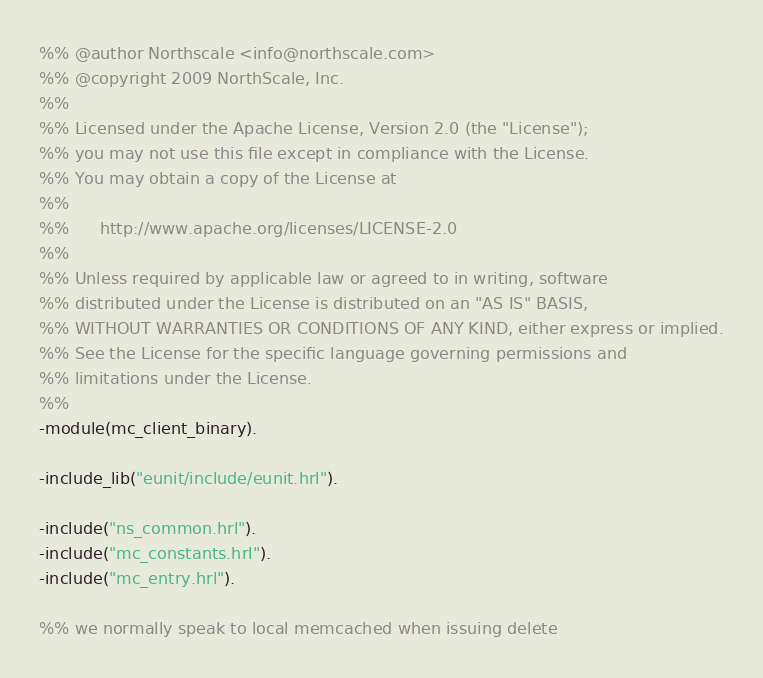Convert code to text. <code><loc_0><loc_0><loc_500><loc_500><_Erlang_>%% @author Northscale <info@northscale.com>
%% @copyright 2009 NorthScale, Inc.
%%
%% Licensed under the Apache License, Version 2.0 (the "License");
%% you may not use this file except in compliance with the License.
%% You may obtain a copy of the License at
%%
%%      http://www.apache.org/licenses/LICENSE-2.0
%%
%% Unless required by applicable law or agreed to in writing, software
%% distributed under the License is distributed on an "AS IS" BASIS,
%% WITHOUT WARRANTIES OR CONDITIONS OF ANY KIND, either express or implied.
%% See the License for the specific language governing permissions and
%% limitations under the License.
%%
-module(mc_client_binary).

-include_lib("eunit/include/eunit.hrl").

-include("ns_common.hrl").
-include("mc_constants.hrl").
-include("mc_entry.hrl").

%% we normally speak to local memcached when issuing delete</code> 